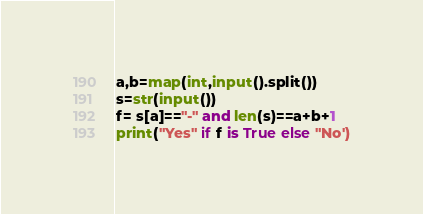Convert code to text. <code><loc_0><loc_0><loc_500><loc_500><_Python_>a,b=map(int,input().split())
s=str(input())
f= s[a]=="-" and len(s)==a+b+1
print("Yes" if f is True else "No')</code> 